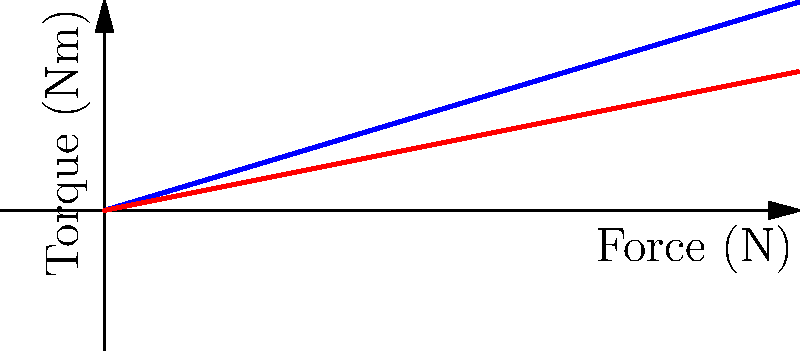The graph shows the relationship between force and torque for the quadriceps and hamstrings during a squat exercise. Based on the data presented, what is the ratio of torque generated by the quadriceps to the hamstrings when a force of 400 N is applied? To solve this problem, we need to follow these steps:

1. Identify the torque values for both muscle groups at 400 N force:
   - For quadriceps: At 400 N, the torque is 120 Nm
   - For hamstrings: At 400 N, the torque is 80 Nm

2. Calculate the ratio of quadriceps torque to hamstrings torque:
   $$ \text{Ratio} = \frac{\text{Quadriceps torque}}{\text{Hamstrings torque}} = \frac{120 \text{ Nm}}{80 \text{ Nm}} = 1.5 $$

3. Simplify the ratio:
   The ratio 1.5 can be expressed as 3:2

Therefore, the ratio of torque generated by the quadriceps to the hamstrings when a force of 400 N is applied is 3:2.
Answer: 3:2 